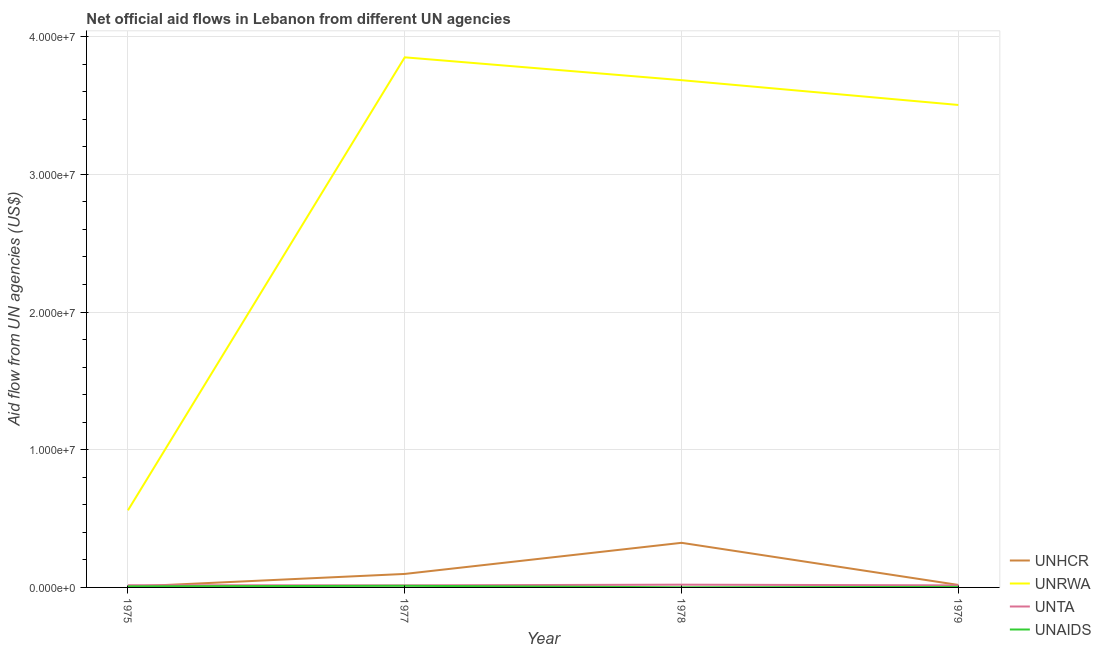How many different coloured lines are there?
Keep it short and to the point. 4. Does the line corresponding to amount of aid given by unhcr intersect with the line corresponding to amount of aid given by unaids?
Your response must be concise. Yes. What is the amount of aid given by unrwa in 1975?
Give a very brief answer. 5.60e+06. Across all years, what is the maximum amount of aid given by unaids?
Your response must be concise. 1.20e+05. Across all years, what is the minimum amount of aid given by unrwa?
Provide a short and direct response. 5.60e+06. In which year was the amount of aid given by unta maximum?
Give a very brief answer. 1978. What is the total amount of aid given by unrwa in the graph?
Offer a very short reply. 1.16e+08. What is the difference between the amount of aid given by unrwa in 1975 and that in 1977?
Give a very brief answer. -3.29e+07. What is the difference between the amount of aid given by unta in 1977 and the amount of aid given by unrwa in 1975?
Make the answer very short. -5.45e+06. What is the average amount of aid given by unaids per year?
Provide a succinct answer. 6.25e+04. In the year 1979, what is the difference between the amount of aid given by unhcr and amount of aid given by unaids?
Keep it short and to the point. 1.40e+05. What is the ratio of the amount of aid given by unrwa in 1975 to that in 1979?
Give a very brief answer. 0.16. Is the amount of aid given by unaids in 1978 less than that in 1979?
Your answer should be very brief. Yes. Is the difference between the amount of aid given by unta in 1977 and 1978 greater than the difference between the amount of aid given by unhcr in 1977 and 1978?
Offer a very short reply. Yes. What is the difference between the highest and the lowest amount of aid given by unta?
Your response must be concise. 5.00e+04. How many years are there in the graph?
Offer a very short reply. 4. What is the difference between two consecutive major ticks on the Y-axis?
Ensure brevity in your answer.  1.00e+07. Are the values on the major ticks of Y-axis written in scientific E-notation?
Ensure brevity in your answer.  Yes. Does the graph contain any zero values?
Your answer should be compact. No. Where does the legend appear in the graph?
Provide a succinct answer. Bottom right. How are the legend labels stacked?
Make the answer very short. Vertical. What is the title of the graph?
Your answer should be very brief. Net official aid flows in Lebanon from different UN agencies. What is the label or title of the Y-axis?
Make the answer very short. Aid flow from UN agencies (US$). What is the Aid flow from UN agencies (US$) in UNHCR in 1975?
Your response must be concise. 5.00e+04. What is the Aid flow from UN agencies (US$) in UNRWA in 1975?
Your response must be concise. 5.60e+06. What is the Aid flow from UN agencies (US$) of UNAIDS in 1975?
Give a very brief answer. 8.00e+04. What is the Aid flow from UN agencies (US$) of UNHCR in 1977?
Ensure brevity in your answer.  9.80e+05. What is the Aid flow from UN agencies (US$) of UNRWA in 1977?
Provide a succinct answer. 3.85e+07. What is the Aid flow from UN agencies (US$) of UNTA in 1977?
Give a very brief answer. 1.50e+05. What is the Aid flow from UN agencies (US$) of UNHCR in 1978?
Provide a succinct answer. 3.24e+06. What is the Aid flow from UN agencies (US$) in UNRWA in 1978?
Provide a succinct answer. 3.68e+07. What is the Aid flow from UN agencies (US$) of UNHCR in 1979?
Provide a short and direct response. 1.80e+05. What is the Aid flow from UN agencies (US$) in UNRWA in 1979?
Keep it short and to the point. 3.50e+07. What is the Aid flow from UN agencies (US$) of UNTA in 1979?
Offer a very short reply. 1.50e+05. What is the Aid flow from UN agencies (US$) in UNAIDS in 1979?
Offer a terse response. 4.00e+04. Across all years, what is the maximum Aid flow from UN agencies (US$) in UNHCR?
Your answer should be compact. 3.24e+06. Across all years, what is the maximum Aid flow from UN agencies (US$) in UNRWA?
Ensure brevity in your answer.  3.85e+07. Across all years, what is the maximum Aid flow from UN agencies (US$) of UNTA?
Offer a very short reply. 2.00e+05. Across all years, what is the maximum Aid flow from UN agencies (US$) of UNAIDS?
Make the answer very short. 1.20e+05. Across all years, what is the minimum Aid flow from UN agencies (US$) in UNRWA?
Your response must be concise. 5.60e+06. Across all years, what is the minimum Aid flow from UN agencies (US$) in UNTA?
Offer a very short reply. 1.50e+05. What is the total Aid flow from UN agencies (US$) in UNHCR in the graph?
Your response must be concise. 4.45e+06. What is the total Aid flow from UN agencies (US$) in UNRWA in the graph?
Provide a short and direct response. 1.16e+08. What is the total Aid flow from UN agencies (US$) of UNTA in the graph?
Your answer should be compact. 6.60e+05. What is the total Aid flow from UN agencies (US$) of UNAIDS in the graph?
Ensure brevity in your answer.  2.50e+05. What is the difference between the Aid flow from UN agencies (US$) of UNHCR in 1975 and that in 1977?
Your response must be concise. -9.30e+05. What is the difference between the Aid flow from UN agencies (US$) of UNRWA in 1975 and that in 1977?
Ensure brevity in your answer.  -3.29e+07. What is the difference between the Aid flow from UN agencies (US$) in UNHCR in 1975 and that in 1978?
Ensure brevity in your answer.  -3.19e+06. What is the difference between the Aid flow from UN agencies (US$) in UNRWA in 1975 and that in 1978?
Your response must be concise. -3.12e+07. What is the difference between the Aid flow from UN agencies (US$) of UNTA in 1975 and that in 1978?
Provide a short and direct response. -4.00e+04. What is the difference between the Aid flow from UN agencies (US$) in UNAIDS in 1975 and that in 1978?
Provide a succinct answer. 7.00e+04. What is the difference between the Aid flow from UN agencies (US$) in UNHCR in 1975 and that in 1979?
Ensure brevity in your answer.  -1.30e+05. What is the difference between the Aid flow from UN agencies (US$) of UNRWA in 1975 and that in 1979?
Offer a terse response. -2.94e+07. What is the difference between the Aid flow from UN agencies (US$) of UNTA in 1975 and that in 1979?
Your response must be concise. 10000. What is the difference between the Aid flow from UN agencies (US$) in UNHCR in 1977 and that in 1978?
Provide a succinct answer. -2.26e+06. What is the difference between the Aid flow from UN agencies (US$) of UNRWA in 1977 and that in 1978?
Your answer should be very brief. 1.66e+06. What is the difference between the Aid flow from UN agencies (US$) of UNTA in 1977 and that in 1978?
Provide a short and direct response. -5.00e+04. What is the difference between the Aid flow from UN agencies (US$) in UNHCR in 1977 and that in 1979?
Your response must be concise. 8.00e+05. What is the difference between the Aid flow from UN agencies (US$) in UNRWA in 1977 and that in 1979?
Your answer should be very brief. 3.46e+06. What is the difference between the Aid flow from UN agencies (US$) in UNAIDS in 1977 and that in 1979?
Offer a very short reply. 8.00e+04. What is the difference between the Aid flow from UN agencies (US$) in UNHCR in 1978 and that in 1979?
Offer a very short reply. 3.06e+06. What is the difference between the Aid flow from UN agencies (US$) in UNRWA in 1978 and that in 1979?
Your answer should be very brief. 1.80e+06. What is the difference between the Aid flow from UN agencies (US$) in UNTA in 1978 and that in 1979?
Your response must be concise. 5.00e+04. What is the difference between the Aid flow from UN agencies (US$) in UNAIDS in 1978 and that in 1979?
Provide a short and direct response. -3.00e+04. What is the difference between the Aid flow from UN agencies (US$) in UNHCR in 1975 and the Aid flow from UN agencies (US$) in UNRWA in 1977?
Provide a succinct answer. -3.84e+07. What is the difference between the Aid flow from UN agencies (US$) in UNHCR in 1975 and the Aid flow from UN agencies (US$) in UNTA in 1977?
Your answer should be compact. -1.00e+05. What is the difference between the Aid flow from UN agencies (US$) of UNHCR in 1975 and the Aid flow from UN agencies (US$) of UNAIDS in 1977?
Offer a terse response. -7.00e+04. What is the difference between the Aid flow from UN agencies (US$) of UNRWA in 1975 and the Aid flow from UN agencies (US$) of UNTA in 1977?
Provide a short and direct response. 5.45e+06. What is the difference between the Aid flow from UN agencies (US$) in UNRWA in 1975 and the Aid flow from UN agencies (US$) in UNAIDS in 1977?
Offer a terse response. 5.48e+06. What is the difference between the Aid flow from UN agencies (US$) of UNTA in 1975 and the Aid flow from UN agencies (US$) of UNAIDS in 1977?
Ensure brevity in your answer.  4.00e+04. What is the difference between the Aid flow from UN agencies (US$) of UNHCR in 1975 and the Aid flow from UN agencies (US$) of UNRWA in 1978?
Keep it short and to the point. -3.68e+07. What is the difference between the Aid flow from UN agencies (US$) of UNHCR in 1975 and the Aid flow from UN agencies (US$) of UNTA in 1978?
Keep it short and to the point. -1.50e+05. What is the difference between the Aid flow from UN agencies (US$) of UNHCR in 1975 and the Aid flow from UN agencies (US$) of UNAIDS in 1978?
Ensure brevity in your answer.  4.00e+04. What is the difference between the Aid flow from UN agencies (US$) of UNRWA in 1975 and the Aid flow from UN agencies (US$) of UNTA in 1978?
Your answer should be very brief. 5.40e+06. What is the difference between the Aid flow from UN agencies (US$) in UNRWA in 1975 and the Aid flow from UN agencies (US$) in UNAIDS in 1978?
Offer a very short reply. 5.59e+06. What is the difference between the Aid flow from UN agencies (US$) of UNTA in 1975 and the Aid flow from UN agencies (US$) of UNAIDS in 1978?
Ensure brevity in your answer.  1.50e+05. What is the difference between the Aid flow from UN agencies (US$) of UNHCR in 1975 and the Aid flow from UN agencies (US$) of UNRWA in 1979?
Offer a terse response. -3.50e+07. What is the difference between the Aid flow from UN agencies (US$) of UNHCR in 1975 and the Aid flow from UN agencies (US$) of UNTA in 1979?
Offer a very short reply. -1.00e+05. What is the difference between the Aid flow from UN agencies (US$) in UNRWA in 1975 and the Aid flow from UN agencies (US$) in UNTA in 1979?
Make the answer very short. 5.45e+06. What is the difference between the Aid flow from UN agencies (US$) in UNRWA in 1975 and the Aid flow from UN agencies (US$) in UNAIDS in 1979?
Keep it short and to the point. 5.56e+06. What is the difference between the Aid flow from UN agencies (US$) in UNTA in 1975 and the Aid flow from UN agencies (US$) in UNAIDS in 1979?
Offer a very short reply. 1.20e+05. What is the difference between the Aid flow from UN agencies (US$) in UNHCR in 1977 and the Aid flow from UN agencies (US$) in UNRWA in 1978?
Offer a very short reply. -3.59e+07. What is the difference between the Aid flow from UN agencies (US$) in UNHCR in 1977 and the Aid flow from UN agencies (US$) in UNTA in 1978?
Provide a succinct answer. 7.80e+05. What is the difference between the Aid flow from UN agencies (US$) of UNHCR in 1977 and the Aid flow from UN agencies (US$) of UNAIDS in 1978?
Offer a very short reply. 9.70e+05. What is the difference between the Aid flow from UN agencies (US$) in UNRWA in 1977 and the Aid flow from UN agencies (US$) in UNTA in 1978?
Your answer should be compact. 3.83e+07. What is the difference between the Aid flow from UN agencies (US$) in UNRWA in 1977 and the Aid flow from UN agencies (US$) in UNAIDS in 1978?
Make the answer very short. 3.85e+07. What is the difference between the Aid flow from UN agencies (US$) of UNHCR in 1977 and the Aid flow from UN agencies (US$) of UNRWA in 1979?
Offer a terse response. -3.41e+07. What is the difference between the Aid flow from UN agencies (US$) of UNHCR in 1977 and the Aid flow from UN agencies (US$) of UNTA in 1979?
Offer a terse response. 8.30e+05. What is the difference between the Aid flow from UN agencies (US$) in UNHCR in 1977 and the Aid flow from UN agencies (US$) in UNAIDS in 1979?
Provide a short and direct response. 9.40e+05. What is the difference between the Aid flow from UN agencies (US$) in UNRWA in 1977 and the Aid flow from UN agencies (US$) in UNTA in 1979?
Make the answer very short. 3.84e+07. What is the difference between the Aid flow from UN agencies (US$) of UNRWA in 1977 and the Aid flow from UN agencies (US$) of UNAIDS in 1979?
Offer a terse response. 3.85e+07. What is the difference between the Aid flow from UN agencies (US$) in UNHCR in 1978 and the Aid flow from UN agencies (US$) in UNRWA in 1979?
Give a very brief answer. -3.18e+07. What is the difference between the Aid flow from UN agencies (US$) of UNHCR in 1978 and the Aid flow from UN agencies (US$) of UNTA in 1979?
Offer a very short reply. 3.09e+06. What is the difference between the Aid flow from UN agencies (US$) of UNHCR in 1978 and the Aid flow from UN agencies (US$) of UNAIDS in 1979?
Your answer should be very brief. 3.20e+06. What is the difference between the Aid flow from UN agencies (US$) in UNRWA in 1978 and the Aid flow from UN agencies (US$) in UNTA in 1979?
Provide a short and direct response. 3.67e+07. What is the difference between the Aid flow from UN agencies (US$) of UNRWA in 1978 and the Aid flow from UN agencies (US$) of UNAIDS in 1979?
Provide a short and direct response. 3.68e+07. What is the average Aid flow from UN agencies (US$) of UNHCR per year?
Ensure brevity in your answer.  1.11e+06. What is the average Aid flow from UN agencies (US$) in UNRWA per year?
Your response must be concise. 2.90e+07. What is the average Aid flow from UN agencies (US$) of UNTA per year?
Your answer should be compact. 1.65e+05. What is the average Aid flow from UN agencies (US$) of UNAIDS per year?
Your answer should be very brief. 6.25e+04. In the year 1975, what is the difference between the Aid flow from UN agencies (US$) in UNHCR and Aid flow from UN agencies (US$) in UNRWA?
Your answer should be very brief. -5.55e+06. In the year 1975, what is the difference between the Aid flow from UN agencies (US$) in UNHCR and Aid flow from UN agencies (US$) in UNTA?
Your answer should be very brief. -1.10e+05. In the year 1975, what is the difference between the Aid flow from UN agencies (US$) in UNHCR and Aid flow from UN agencies (US$) in UNAIDS?
Your answer should be compact. -3.00e+04. In the year 1975, what is the difference between the Aid flow from UN agencies (US$) in UNRWA and Aid flow from UN agencies (US$) in UNTA?
Your answer should be compact. 5.44e+06. In the year 1975, what is the difference between the Aid flow from UN agencies (US$) of UNRWA and Aid flow from UN agencies (US$) of UNAIDS?
Ensure brevity in your answer.  5.52e+06. In the year 1975, what is the difference between the Aid flow from UN agencies (US$) in UNTA and Aid flow from UN agencies (US$) in UNAIDS?
Your answer should be very brief. 8.00e+04. In the year 1977, what is the difference between the Aid flow from UN agencies (US$) of UNHCR and Aid flow from UN agencies (US$) of UNRWA?
Ensure brevity in your answer.  -3.75e+07. In the year 1977, what is the difference between the Aid flow from UN agencies (US$) in UNHCR and Aid flow from UN agencies (US$) in UNTA?
Make the answer very short. 8.30e+05. In the year 1977, what is the difference between the Aid flow from UN agencies (US$) in UNHCR and Aid flow from UN agencies (US$) in UNAIDS?
Keep it short and to the point. 8.60e+05. In the year 1977, what is the difference between the Aid flow from UN agencies (US$) of UNRWA and Aid flow from UN agencies (US$) of UNTA?
Ensure brevity in your answer.  3.84e+07. In the year 1977, what is the difference between the Aid flow from UN agencies (US$) of UNRWA and Aid flow from UN agencies (US$) of UNAIDS?
Give a very brief answer. 3.84e+07. In the year 1978, what is the difference between the Aid flow from UN agencies (US$) of UNHCR and Aid flow from UN agencies (US$) of UNRWA?
Provide a short and direct response. -3.36e+07. In the year 1978, what is the difference between the Aid flow from UN agencies (US$) of UNHCR and Aid flow from UN agencies (US$) of UNTA?
Keep it short and to the point. 3.04e+06. In the year 1978, what is the difference between the Aid flow from UN agencies (US$) of UNHCR and Aid flow from UN agencies (US$) of UNAIDS?
Offer a terse response. 3.23e+06. In the year 1978, what is the difference between the Aid flow from UN agencies (US$) in UNRWA and Aid flow from UN agencies (US$) in UNTA?
Offer a very short reply. 3.66e+07. In the year 1978, what is the difference between the Aid flow from UN agencies (US$) of UNRWA and Aid flow from UN agencies (US$) of UNAIDS?
Offer a terse response. 3.68e+07. In the year 1978, what is the difference between the Aid flow from UN agencies (US$) in UNTA and Aid flow from UN agencies (US$) in UNAIDS?
Your answer should be very brief. 1.90e+05. In the year 1979, what is the difference between the Aid flow from UN agencies (US$) of UNHCR and Aid flow from UN agencies (US$) of UNRWA?
Give a very brief answer. -3.49e+07. In the year 1979, what is the difference between the Aid flow from UN agencies (US$) of UNHCR and Aid flow from UN agencies (US$) of UNTA?
Keep it short and to the point. 3.00e+04. In the year 1979, what is the difference between the Aid flow from UN agencies (US$) of UNHCR and Aid flow from UN agencies (US$) of UNAIDS?
Ensure brevity in your answer.  1.40e+05. In the year 1979, what is the difference between the Aid flow from UN agencies (US$) of UNRWA and Aid flow from UN agencies (US$) of UNTA?
Make the answer very short. 3.49e+07. In the year 1979, what is the difference between the Aid flow from UN agencies (US$) in UNRWA and Aid flow from UN agencies (US$) in UNAIDS?
Your answer should be compact. 3.50e+07. What is the ratio of the Aid flow from UN agencies (US$) in UNHCR in 1975 to that in 1977?
Provide a succinct answer. 0.05. What is the ratio of the Aid flow from UN agencies (US$) of UNRWA in 1975 to that in 1977?
Keep it short and to the point. 0.15. What is the ratio of the Aid flow from UN agencies (US$) of UNTA in 1975 to that in 1977?
Make the answer very short. 1.07. What is the ratio of the Aid flow from UN agencies (US$) in UNAIDS in 1975 to that in 1977?
Keep it short and to the point. 0.67. What is the ratio of the Aid flow from UN agencies (US$) in UNHCR in 1975 to that in 1978?
Provide a short and direct response. 0.02. What is the ratio of the Aid flow from UN agencies (US$) in UNRWA in 1975 to that in 1978?
Provide a succinct answer. 0.15. What is the ratio of the Aid flow from UN agencies (US$) of UNAIDS in 1975 to that in 1978?
Your answer should be compact. 8. What is the ratio of the Aid flow from UN agencies (US$) of UNHCR in 1975 to that in 1979?
Provide a short and direct response. 0.28. What is the ratio of the Aid flow from UN agencies (US$) in UNRWA in 1975 to that in 1979?
Your answer should be very brief. 0.16. What is the ratio of the Aid flow from UN agencies (US$) of UNTA in 1975 to that in 1979?
Keep it short and to the point. 1.07. What is the ratio of the Aid flow from UN agencies (US$) of UNAIDS in 1975 to that in 1979?
Make the answer very short. 2. What is the ratio of the Aid flow from UN agencies (US$) of UNHCR in 1977 to that in 1978?
Offer a very short reply. 0.3. What is the ratio of the Aid flow from UN agencies (US$) of UNRWA in 1977 to that in 1978?
Provide a succinct answer. 1.05. What is the ratio of the Aid flow from UN agencies (US$) in UNHCR in 1977 to that in 1979?
Offer a very short reply. 5.44. What is the ratio of the Aid flow from UN agencies (US$) in UNRWA in 1977 to that in 1979?
Give a very brief answer. 1.1. What is the ratio of the Aid flow from UN agencies (US$) of UNRWA in 1978 to that in 1979?
Your response must be concise. 1.05. What is the ratio of the Aid flow from UN agencies (US$) of UNTA in 1978 to that in 1979?
Your answer should be compact. 1.33. What is the difference between the highest and the second highest Aid flow from UN agencies (US$) of UNHCR?
Give a very brief answer. 2.26e+06. What is the difference between the highest and the second highest Aid flow from UN agencies (US$) in UNRWA?
Keep it short and to the point. 1.66e+06. What is the difference between the highest and the lowest Aid flow from UN agencies (US$) in UNHCR?
Provide a succinct answer. 3.19e+06. What is the difference between the highest and the lowest Aid flow from UN agencies (US$) of UNRWA?
Provide a succinct answer. 3.29e+07. What is the difference between the highest and the lowest Aid flow from UN agencies (US$) of UNTA?
Keep it short and to the point. 5.00e+04. What is the difference between the highest and the lowest Aid flow from UN agencies (US$) in UNAIDS?
Your answer should be very brief. 1.10e+05. 